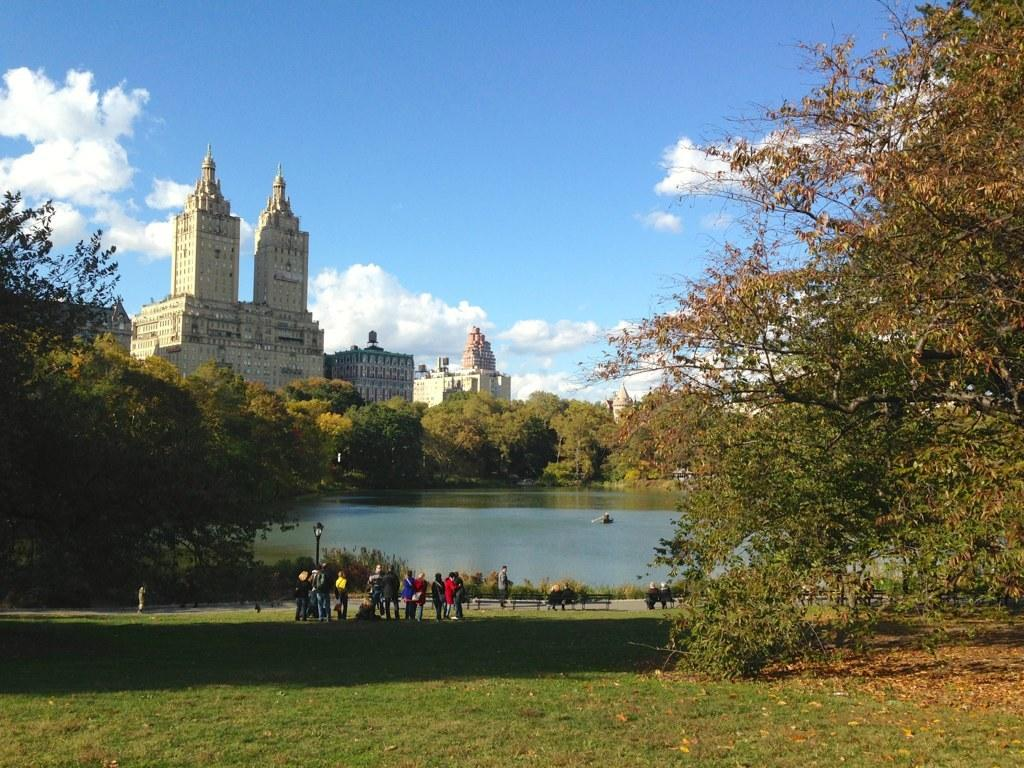Who or what can be seen in the image? There are people in the image. What type of structures are present in the image? There are buildings in the image. What type of vegetation is visible in the image? There are plants and trees in the image. What natural element can be seen in the image? There is water visible in the image. What part of the natural environment is visible in the image? The sky is visible in the image. How many quarters can be seen in the image? There are no quarters present in the image. What type of hen is depicted in the image? There is no hen present in the image. 